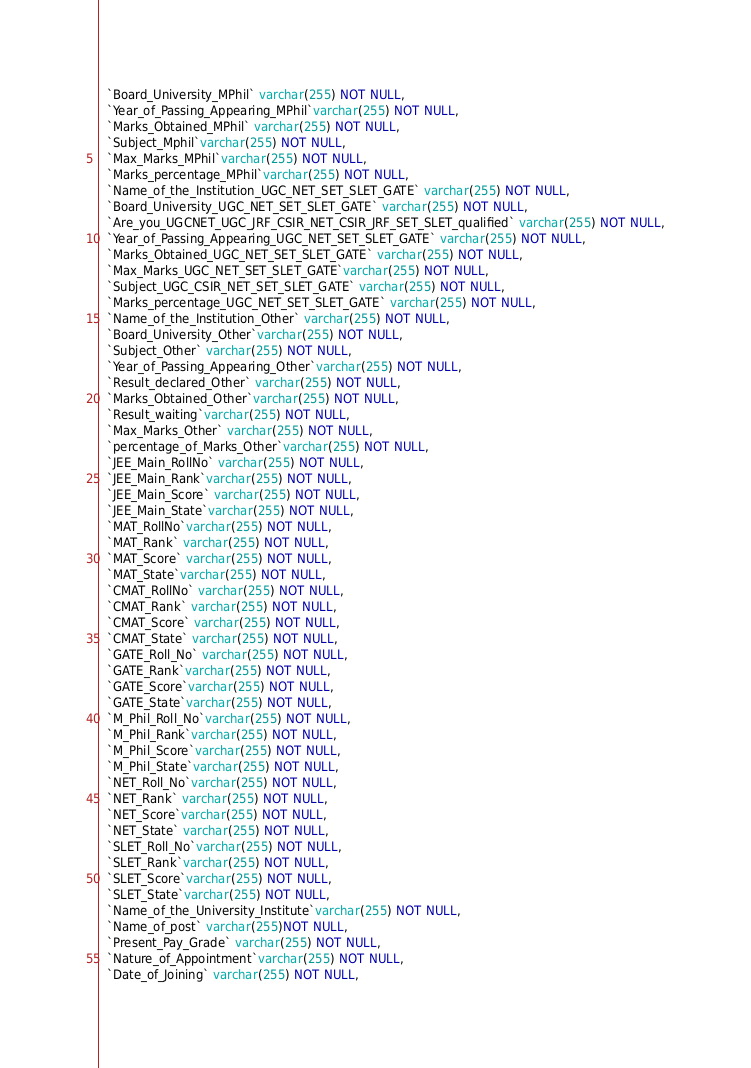<code> <loc_0><loc_0><loc_500><loc_500><_SQL_>  `Board_University_MPhil` varchar(255) NOT NULL,
  `Year_of_Passing_Appearing_MPhil`varchar(255) NOT NULL, 
  `Marks_Obtained_MPhil` varchar(255) NOT NULL,
  `Subject_Mphil`varchar(255) NOT NULL,
  `Max_Marks_MPhil`varchar(255) NOT NULL,
  `Marks_percentage_MPhil`varchar(255) NOT NULL,
  `Name_of_the_Institution_UGC_NET_SET_SLET_GATE` varchar(255) NOT NULL,
  `Board_University_UGC_NET_SET_SLET_GATE` varchar(255) NOT NULL,
  `Are_you_UGCNET_UGC_JRF_CSIR_NET_CSIR_JRF_SET_SLET_qualified` varchar(255) NOT NULL,
  `Year_of_Passing_Appearing_UGC_NET_SET_SLET_GATE` varchar(255) NOT NULL,
  `Marks_Obtained_UGC_NET_SET_SLET_GATE` varchar(255) NOT NULL,
  `Max_Marks_UGC_NET_SET_SLET_GATE`varchar(255) NOT NULL,
  `Subject_UGC_CSIR_NET_SET_SLET_GATE` varchar(255) NOT NULL,
  `Marks_percentage_UGC_NET_SET_SLET_GATE` varchar(255) NOT NULL,
  `Name_of_the_Institution_Other` varchar(255) NOT NULL,
  `Board_University_Other`varchar(255) NOT NULL,
  `Subject_Other` varchar(255) NOT NULL,
  `Year_of_Passing_Appearing_Other`varchar(255) NOT NULL,
  `Result_declared_Other` varchar(255) NOT NULL,
  `Marks_Obtained_Other`varchar(255) NOT NULL,
  `Result_waiting`varchar(255) NOT NULL,  
  `Max_Marks_Other` varchar(255) NOT NULL,
  `percentage_of_Marks_Other`varchar(255) NOT NULL,
  `JEE_Main_RollNo` varchar(255) NOT NULL,
  `JEE_Main_Rank`varchar(255) NOT NULL,
  `JEE_Main_Score` varchar(255) NOT NULL,
  `JEE_Main_State`varchar(255) NOT NULL,
  `MAT_RollNo`varchar(255) NOT NULL,
  `MAT_Rank` varchar(255) NOT NULL,
  `MAT_Score` varchar(255) NOT NULL,
  `MAT_State`varchar(255) NOT NULL,
  `CMAT_RollNo` varchar(255) NOT NULL,
  `CMAT_Rank` varchar(255) NOT NULL,
  `CMAT_Score` varchar(255) NOT NULL,
  `CMAT_State` varchar(255) NOT NULL,
  `GATE_Roll_No` varchar(255) NOT NULL,
  `GATE_Rank`varchar(255) NOT NULL,
  `GATE_Score`varchar(255) NOT NULL,
  `GATE_State`varchar(255) NOT NULL,
  `M_Phil_Roll_No`varchar(255) NOT NULL,
  `M_Phil_Rank`varchar(255) NOT NULL,
  `M_Phil_Score`varchar(255) NOT NULL,
  `M_Phil_State`varchar(255) NOT NULL,
  `NET_Roll_No`varchar(255) NOT NULL,
  `NET_Rank` varchar(255) NOT NULL,
  `NET_Score`varchar(255) NOT NULL,
  `NET_State` varchar(255) NOT NULL,
  `SLET_Roll_No`varchar(255) NOT NULL,
  `SLET_Rank`varchar(255) NOT NULL,
  `SLET_Score`varchar(255) NOT NULL,
  `SLET_State`varchar(255) NOT NULL,
  `Name_of_the_University_Institute`varchar(255) NOT NULL,
  `Name_of_post` varchar(255)NOT NULL,
  `Present_Pay_Grade` varchar(255) NOT NULL,
  `Nature_of_Appointment`varchar(255) NOT NULL,
  `Date_of_Joining` varchar(255) NOT NULL,</code> 